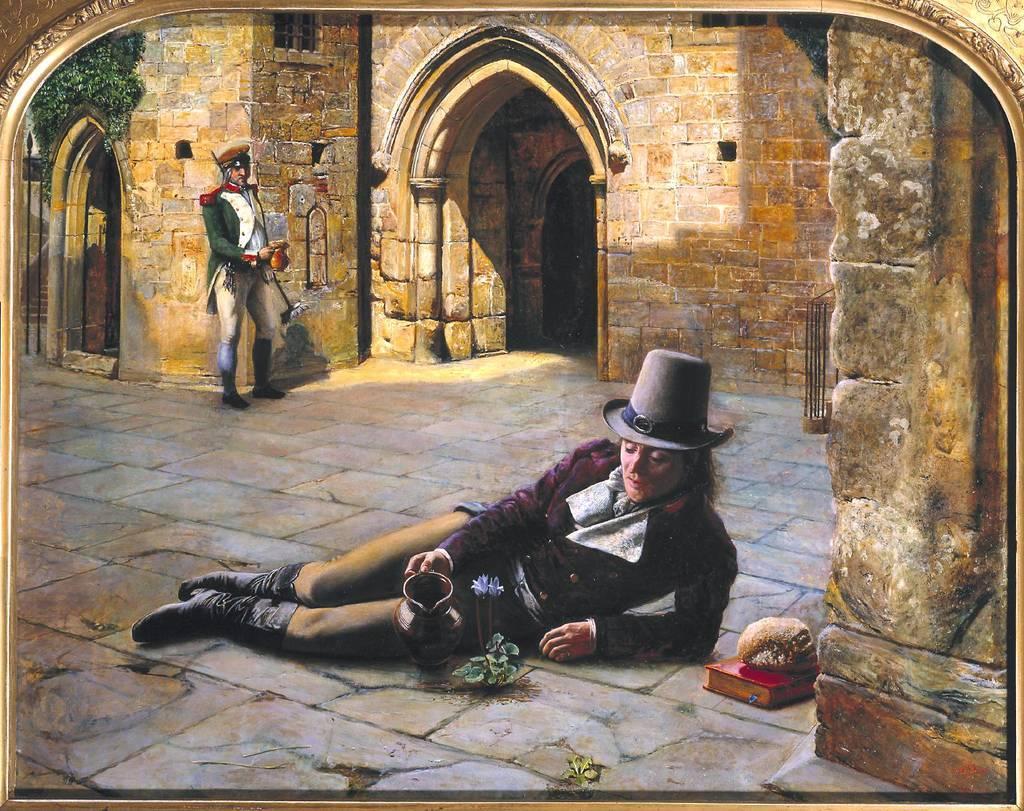Could you give a brief overview of what you see in this image? In this image a person sleeping on the floor holding a mug. Another person is standing on the back side. It is a stone building. 